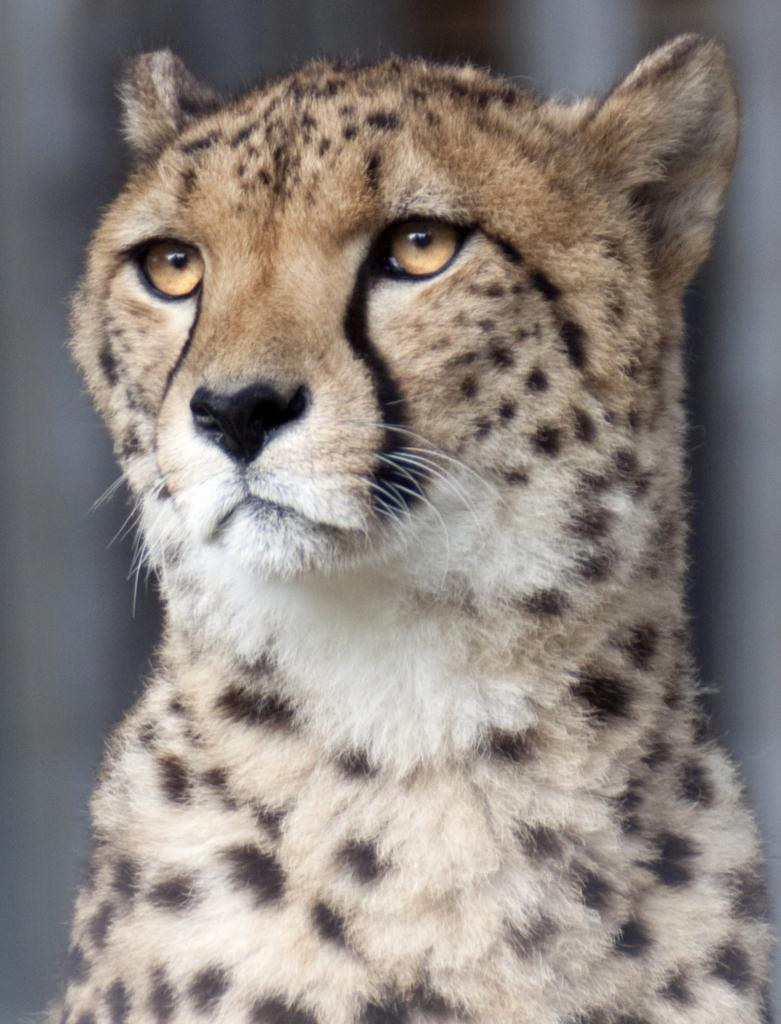What type of animal is in the image? There is a leopard in the image. What colors can be seen on the leopard? The leopard's color is white, cream, and black. Can you describe the background of the image? The background of the image is blurry. Where is the market located in the image? There is no market in the image; it features a leopard with a white, cream, and black coloration against a blurry background. 